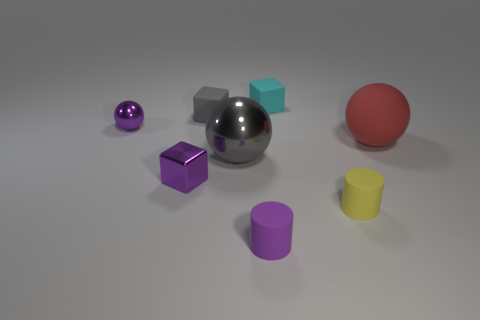How many cyan shiny objects are the same shape as the large matte thing?
Ensure brevity in your answer.  0. Is the number of tiny purple objects that are behind the small purple matte object greater than the number of purple objects?
Offer a very short reply. No. What is the shape of the rubber object to the left of the metal ball that is in front of the purple object behind the red thing?
Your answer should be compact. Cube. There is a tiny rubber thing that is behind the tiny gray thing; does it have the same shape as the small metallic thing that is in front of the small purple metal sphere?
Your response must be concise. Yes. How many balls are either yellow things or shiny things?
Keep it short and to the point. 2. Is the material of the tiny yellow cylinder the same as the tiny purple cube?
Offer a very short reply. No. How many other objects are there of the same color as the tiny shiny ball?
Your response must be concise. 2. The big thing behind the large shiny sphere has what shape?
Your response must be concise. Sphere. What number of things are either brown balls or tiny cubes?
Provide a succinct answer. 3. Is the size of the purple metallic cube the same as the sphere that is on the right side of the small yellow matte cylinder?
Your answer should be very brief. No. 